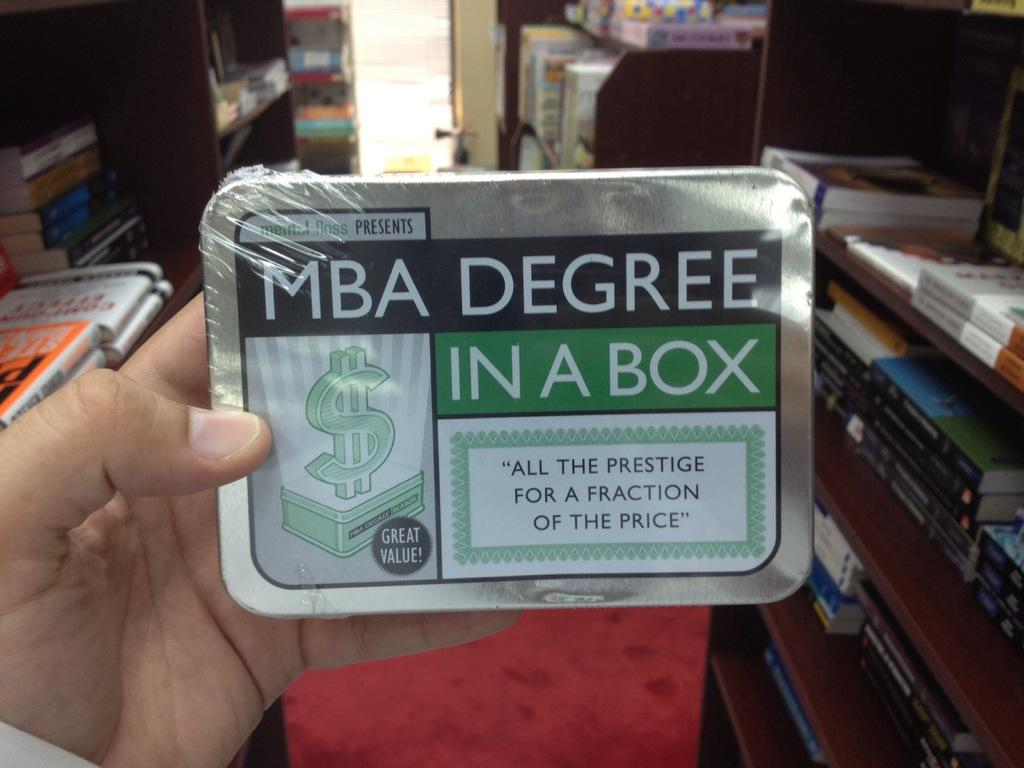<image>
Present a compact description of the photo's key features. A Mental Floss MBA Degree in a Box that is a great value 